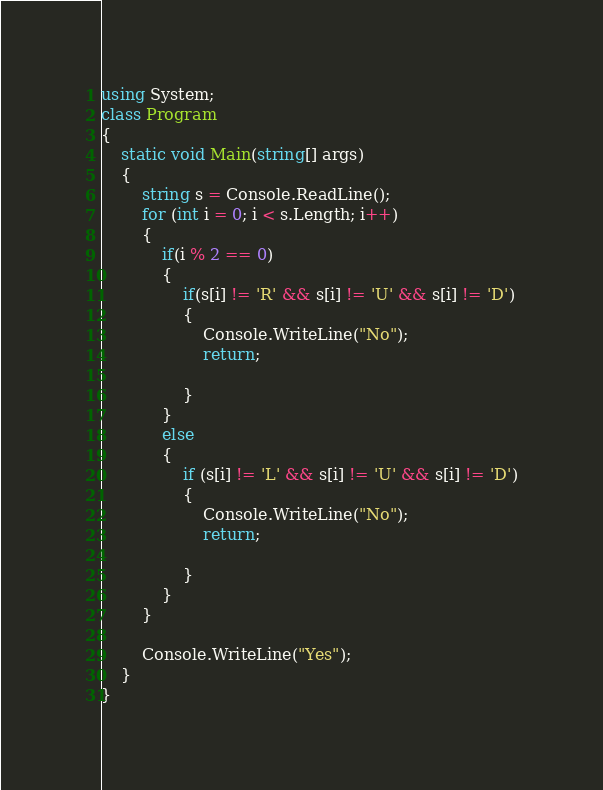Convert code to text. <code><loc_0><loc_0><loc_500><loc_500><_C#_>using System;
class Program
{
    static void Main(string[] args)
    {
        string s = Console.ReadLine();
        for (int i = 0; i < s.Length; i++)
        {
            if(i % 2 == 0)
            {
                if(s[i] != 'R' && s[i] != 'U' && s[i] != 'D')
                {
                    Console.WriteLine("No");
                    return;

                }
            }
            else
            {
                if (s[i] != 'L' && s[i] != 'U' && s[i] != 'D')
                {
                    Console.WriteLine("No");
                    return;

                }
            }
        }

        Console.WriteLine("Yes");
    }
}</code> 